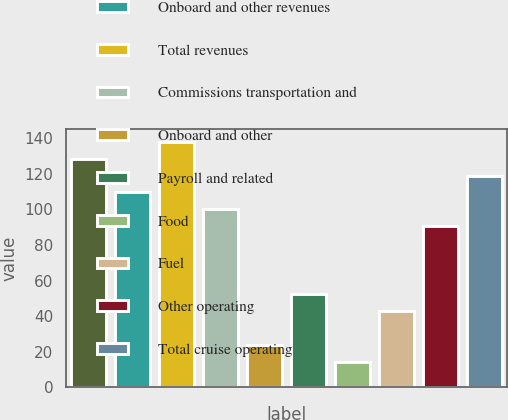Convert chart to OTSL. <chart><loc_0><loc_0><loc_500><loc_500><bar_chart><fcel>Passenger ticket revenues<fcel>Onboard and other revenues<fcel>Total revenues<fcel>Commissions transportation and<fcel>Onboard and other<fcel>Payroll and related<fcel>Food<fcel>Fuel<fcel>Other operating<fcel>Total cruise operating<nl><fcel>128.53<fcel>109.51<fcel>138.04<fcel>100<fcel>23.92<fcel>52.45<fcel>14.41<fcel>42.94<fcel>90.49<fcel>119.02<nl></chart> 